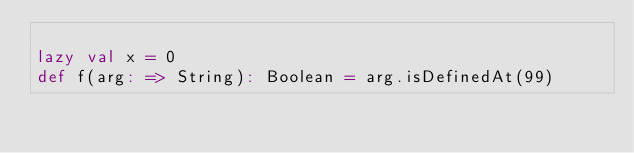<code> <loc_0><loc_0><loc_500><loc_500><_Scala_>
lazy val x = 0
def f(arg: => String): Boolean = arg.isDefinedAt(99)
</code> 